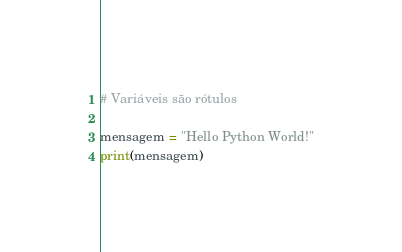<code> <loc_0><loc_0><loc_500><loc_500><_Python_># Variáveis são rótulos

mensagem = "Hello Python World!"
print(mensagem)
</code> 